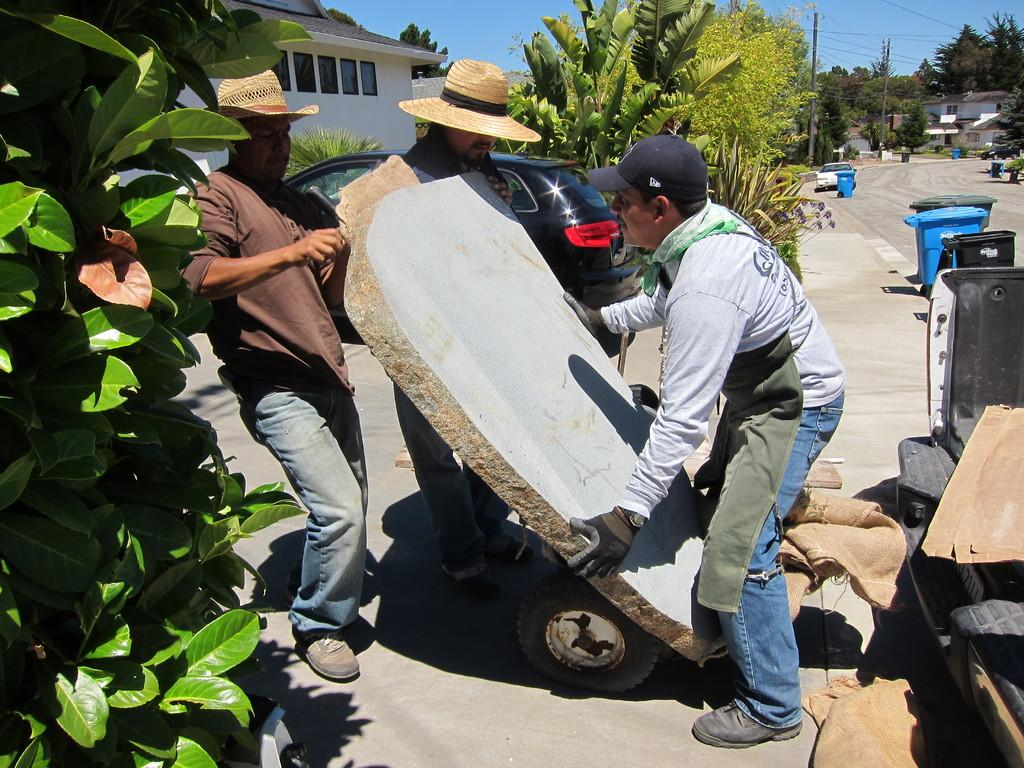What are the people in the image doing? The people in the image are carrying an object. What can be seen besides the people in the image? There are plants, trees, and a pole in the image. What is the condition of the sky in the image? The sky is clear in the image. How hot is the object being carried by the people in the image? The provided facts do not mention the temperature of the object, so it cannot be determined from the image. --- Facts: 1. There is a person sitting on a chair in the image. 2. The person is holding a book. 3. There is a table next to the chair. 4. There is a lamp on the table. 5. The background of the image is a room. Absurd Topics: dance, ocean, parrot Conversation: What is the person in the image doing? The person in the image is sitting on a chair. What is the person holding in the image? The person is holding a book. What is located next to the chair in the image? There is a table next to the chair. What is on the table in the image? There is a lamp on the table. What is the setting of the image? The background of the image is a room. Reasoning: Let's think step by step in order to produce the conversation. We start by identifying the main subject in the image, which is the person sitting on a chair. Then, we expand the conversation to include other items that are also visible, such as the book, table, lamp, and the room setting. Each question is designed to elicit a specific detail about the image that is known from the provided facts. Absurd Question/Answer: Can you see any parrots in the image? There are no parrots present in the image. Is the person dancing in the image? The provided facts do not mention any dancing, so it cannot be determined from the image. --- Facts: 1. There is a car in the image. 2. The car is parked on the street. 3. There are trees on the street. 4. There is a sidewalk next to the street. 5. The sky is visible in the image. Absurd Topics: fish, mountain, bicycle Conversation: What is the main subject of the image? The main subject of the image is a car. Where is the car located in the image? The car is parked on the street. What else can be seen on the street in the image? There are trees on the street. What is located next to the street in the image? There is a sidewalk next to the street. What is visible in the background of the image? The sky is visible in the image. Reasoning: Let 